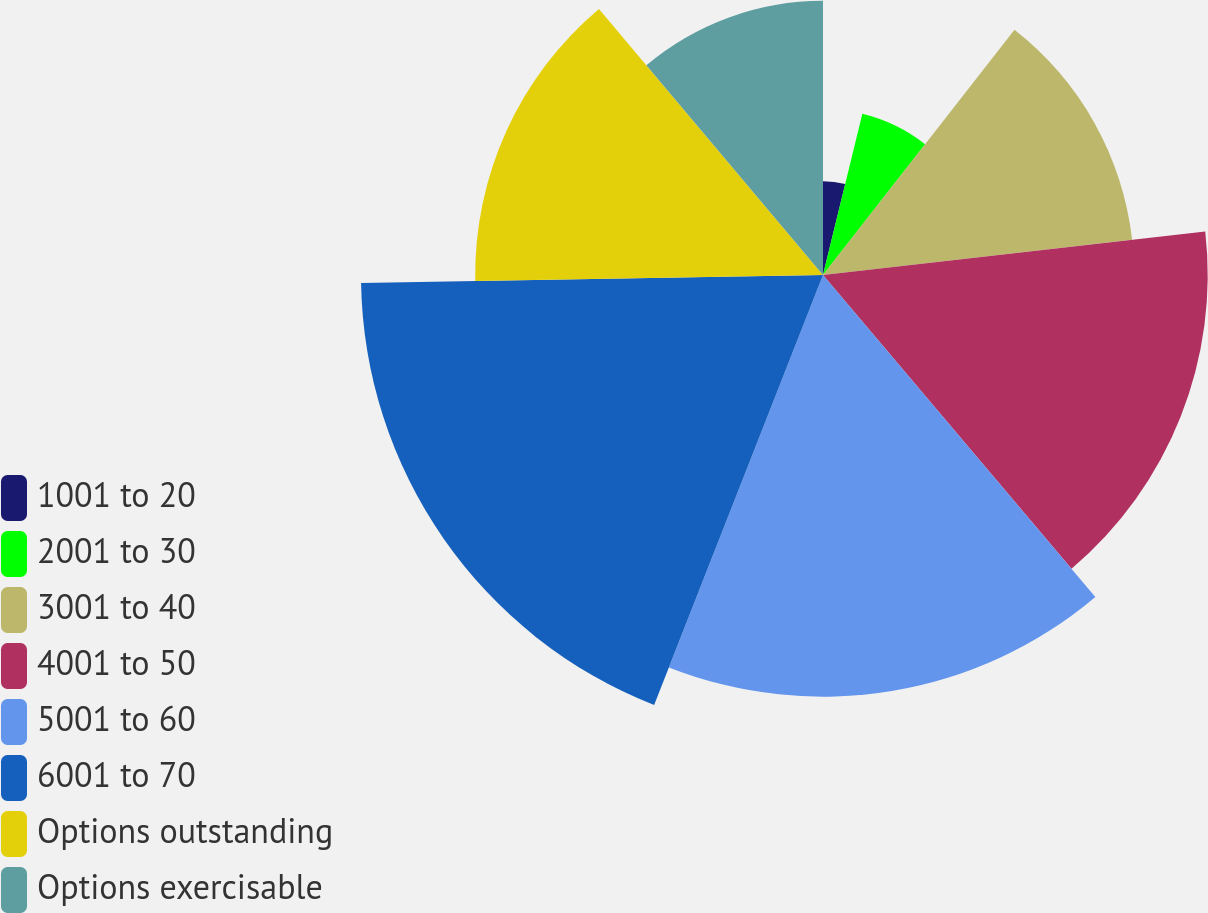Convert chart. <chart><loc_0><loc_0><loc_500><loc_500><pie_chart><fcel>1001 to 20<fcel>2001 to 30<fcel>3001 to 40<fcel>4001 to 50<fcel>5001 to 60<fcel>6001 to 70<fcel>Options outstanding<fcel>Options exercisable<nl><fcel>3.81%<fcel>6.74%<fcel>12.64%<fcel>15.63%<fcel>17.13%<fcel>18.77%<fcel>14.13%<fcel>11.14%<nl></chart> 